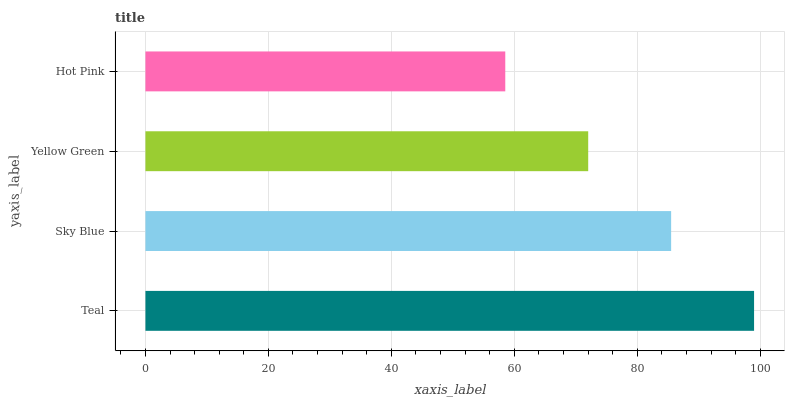Is Hot Pink the minimum?
Answer yes or no. Yes. Is Teal the maximum?
Answer yes or no. Yes. Is Sky Blue the minimum?
Answer yes or no. No. Is Sky Blue the maximum?
Answer yes or no. No. Is Teal greater than Sky Blue?
Answer yes or no. Yes. Is Sky Blue less than Teal?
Answer yes or no. Yes. Is Sky Blue greater than Teal?
Answer yes or no. No. Is Teal less than Sky Blue?
Answer yes or no. No. Is Sky Blue the high median?
Answer yes or no. Yes. Is Yellow Green the low median?
Answer yes or no. Yes. Is Hot Pink the high median?
Answer yes or no. No. Is Teal the low median?
Answer yes or no. No. 